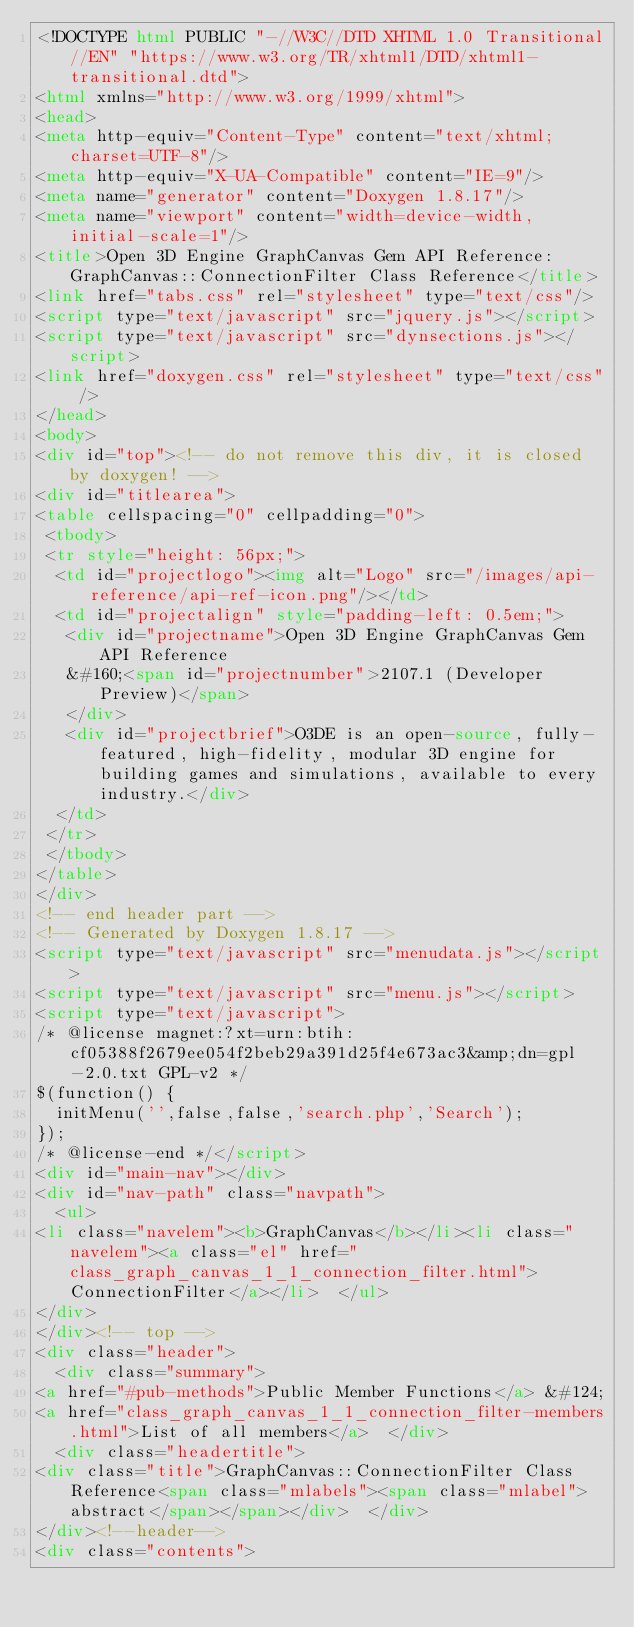Convert code to text. <code><loc_0><loc_0><loc_500><loc_500><_HTML_><!DOCTYPE html PUBLIC "-//W3C//DTD XHTML 1.0 Transitional//EN" "https://www.w3.org/TR/xhtml1/DTD/xhtml1-transitional.dtd">
<html xmlns="http://www.w3.org/1999/xhtml">
<head>
<meta http-equiv="Content-Type" content="text/xhtml;charset=UTF-8"/>
<meta http-equiv="X-UA-Compatible" content="IE=9"/>
<meta name="generator" content="Doxygen 1.8.17"/>
<meta name="viewport" content="width=device-width, initial-scale=1"/>
<title>Open 3D Engine GraphCanvas Gem API Reference: GraphCanvas::ConnectionFilter Class Reference</title>
<link href="tabs.css" rel="stylesheet" type="text/css"/>
<script type="text/javascript" src="jquery.js"></script>
<script type="text/javascript" src="dynsections.js"></script>
<link href="doxygen.css" rel="stylesheet" type="text/css" />
</head>
<body>
<div id="top"><!-- do not remove this div, it is closed by doxygen! -->
<div id="titlearea">
<table cellspacing="0" cellpadding="0">
 <tbody>
 <tr style="height: 56px;">
  <td id="projectlogo"><img alt="Logo" src="/images/api-reference/api-ref-icon.png"/></td>
  <td id="projectalign" style="padding-left: 0.5em;">
   <div id="projectname">Open 3D Engine GraphCanvas Gem API Reference
   &#160;<span id="projectnumber">2107.1 (Developer Preview)</span>
   </div>
   <div id="projectbrief">O3DE is an open-source, fully-featured, high-fidelity, modular 3D engine for building games and simulations, available to every industry.</div>
  </td>
 </tr>
 </tbody>
</table>
</div>
<!-- end header part -->
<!-- Generated by Doxygen 1.8.17 -->
<script type="text/javascript" src="menudata.js"></script>
<script type="text/javascript" src="menu.js"></script>
<script type="text/javascript">
/* @license magnet:?xt=urn:btih:cf05388f2679ee054f2beb29a391d25f4e673ac3&amp;dn=gpl-2.0.txt GPL-v2 */
$(function() {
  initMenu('',false,false,'search.php','Search');
});
/* @license-end */</script>
<div id="main-nav"></div>
<div id="nav-path" class="navpath">
  <ul>
<li class="navelem"><b>GraphCanvas</b></li><li class="navelem"><a class="el" href="class_graph_canvas_1_1_connection_filter.html">ConnectionFilter</a></li>  </ul>
</div>
</div><!-- top -->
<div class="header">
  <div class="summary">
<a href="#pub-methods">Public Member Functions</a> &#124;
<a href="class_graph_canvas_1_1_connection_filter-members.html">List of all members</a>  </div>
  <div class="headertitle">
<div class="title">GraphCanvas::ConnectionFilter Class Reference<span class="mlabels"><span class="mlabel">abstract</span></span></div>  </div>
</div><!--header-->
<div class="contents">
</code> 